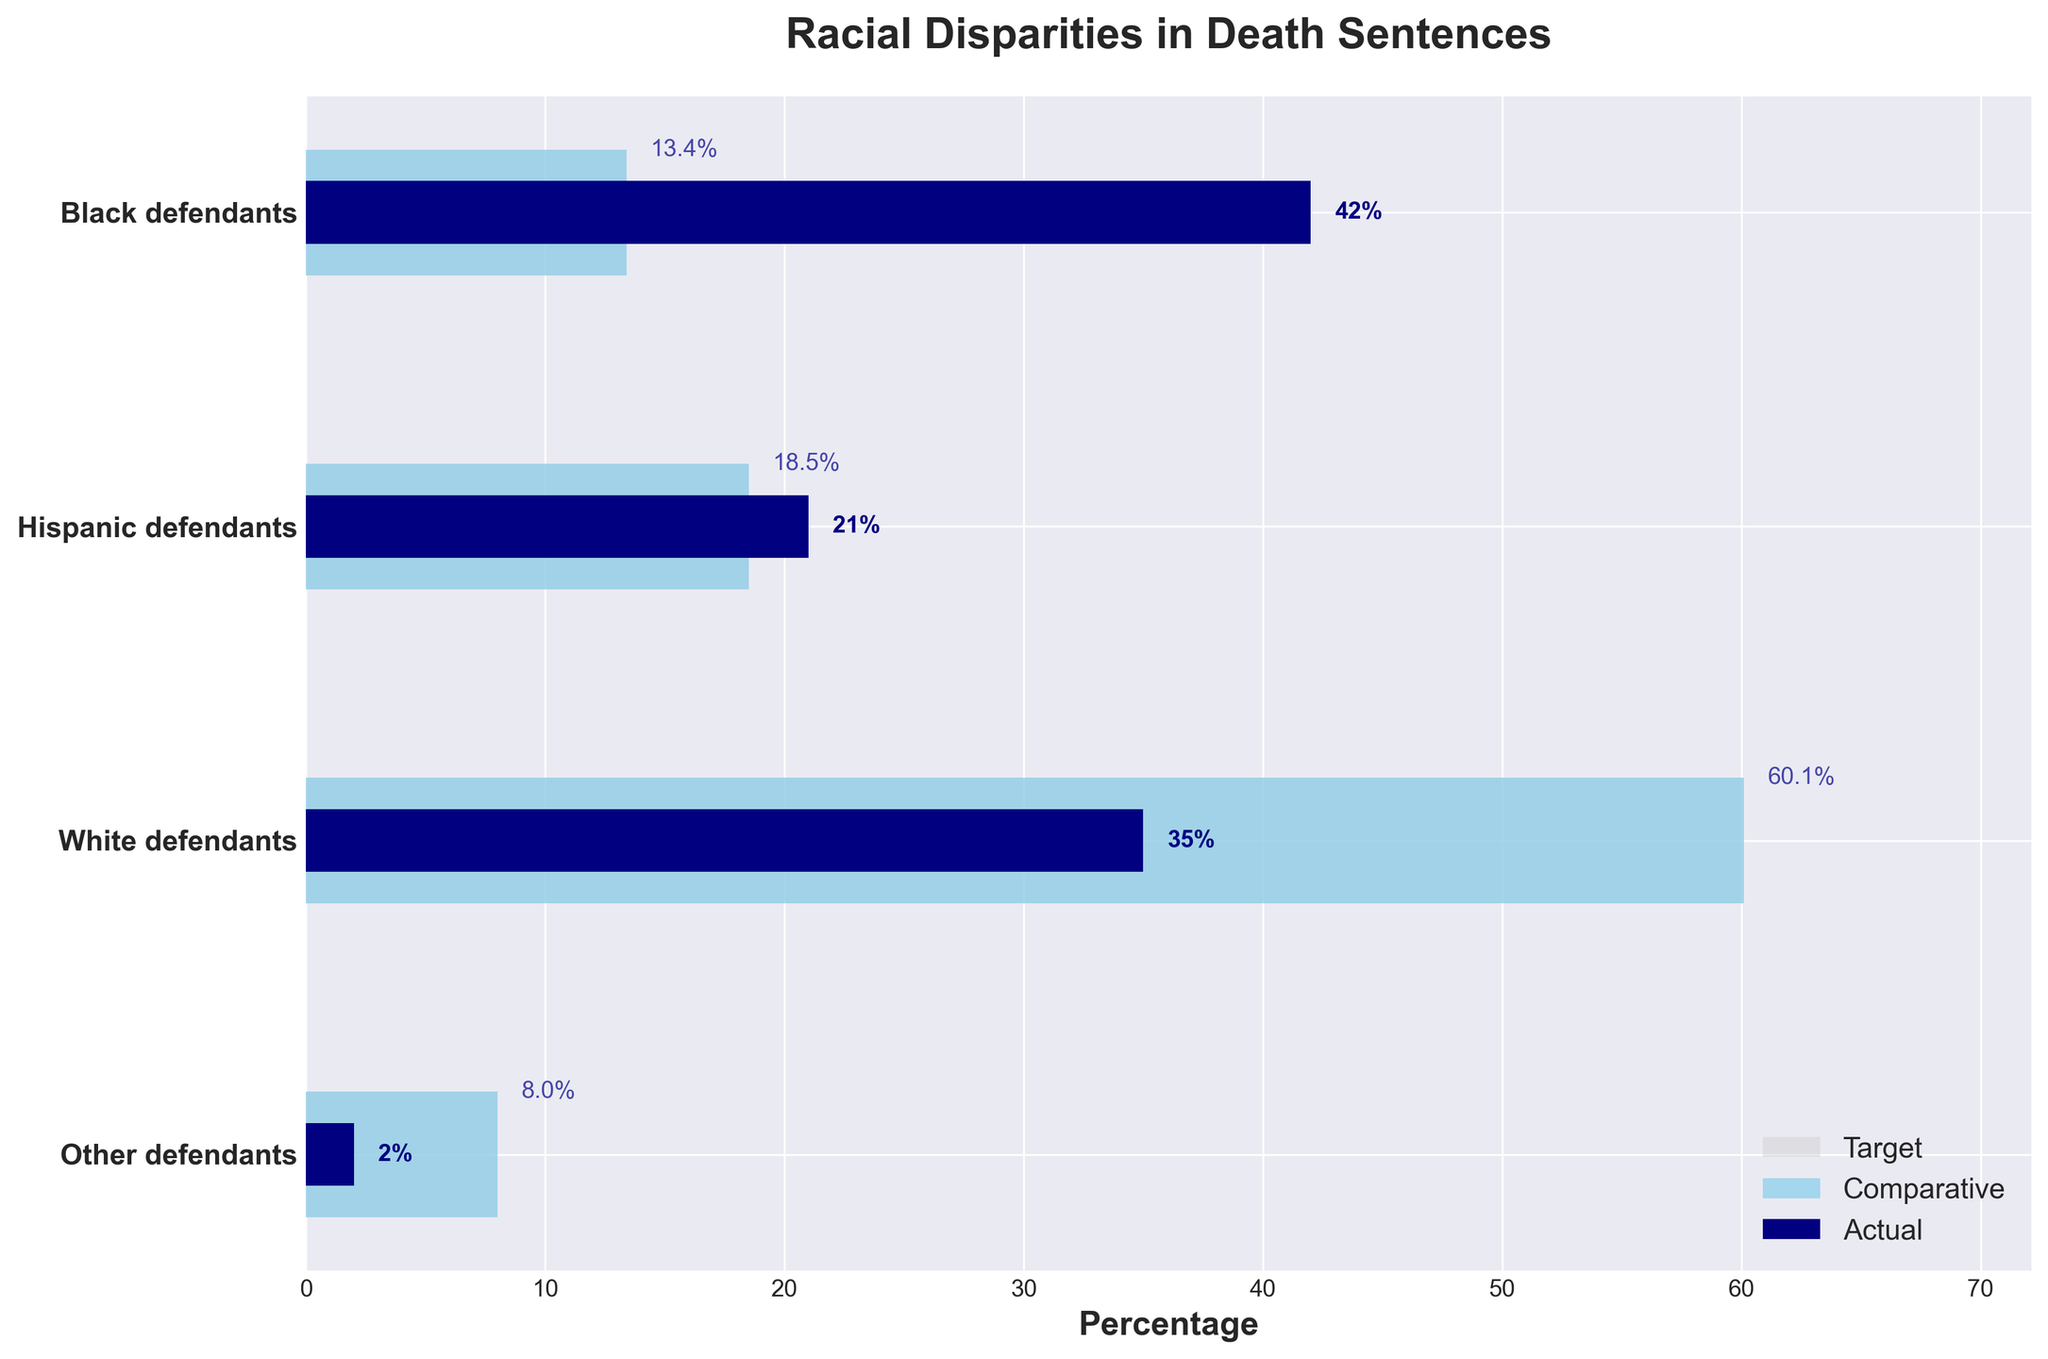How many groups are visualized in the bullet chart? The bullet chart shows different racial groups with their corresponding percentages. There's one bar for each group. By counting the bars, we can determine the number of groups.
Answer: 4 Which racial group has the highest actual percentage of death sentences? To find the racial group with the highest actual percentage, we look at the darkest bars representing the actual values. Comparing these bars, we see that "Black defendants" has the highest value.
Answer: Black defendants How does the percentage of actual death sentences for Hispanic defendants compare to their population demographics? To compare the actual death sentence percentage with the population demographics for Hispanic defendants, compare the smallest dark blue bar (actual) with the skyblue bar (comparative). The actual percentage is much higher than the comparative percentage.
Answer: Higher What is the difference between the actual and comparative percentages of death sentences for White defendants? Subtract the comparative percentage value from the actual percentage value for White defendants: Actual (35%) - Comparative (60.1%) = -25.1%.
Answer: -25.1% Which racial group has the smallest disparity between the actual and target percentages? To find the smallest disparity, compare the difference between the actual and target values for each group. The smallest difference we find is with the group “Black defendants”, since its values closely meet its target value.
Answer: Black defendants Which racial group has the lowest actual percentage of death sentences? By observing the shortest dark blue bar, we conclude that "Other defendants" has the lowest actual percentage.
Answer: Other defendants What is the combined actual percentage of death sentences for Hispanic and Other defendants? To get the combined percentage, add the actual percentages of Hispanic defendants (21%) and Other defendants (2%): 21 + 2 = 23%.
Answer: 23% How does the actual percentage for White defendants compare to the actual percentage for Black defendants? Compare the lengths of the dark blue bars (actual) for White (35%) and Black (42%) defendants. The actual percentage for White defendants is lower than that for Black defendants.
Answer: Lower What is the median percentage of actual death sentences across all racial groups? To find the median, arrange the actual percentages in ascending order: 2%, 21%, 35%, 42%. The two middle values are 21% and 35%. The median is the average of these two values: (21 + 35) / 2 = 28%.
Answer: 28% 